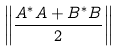Convert formula to latex. <formula><loc_0><loc_0><loc_500><loc_500>\left \| \frac { A ^ { \ast } A + B ^ { \ast } B } { 2 } \right \|</formula> 